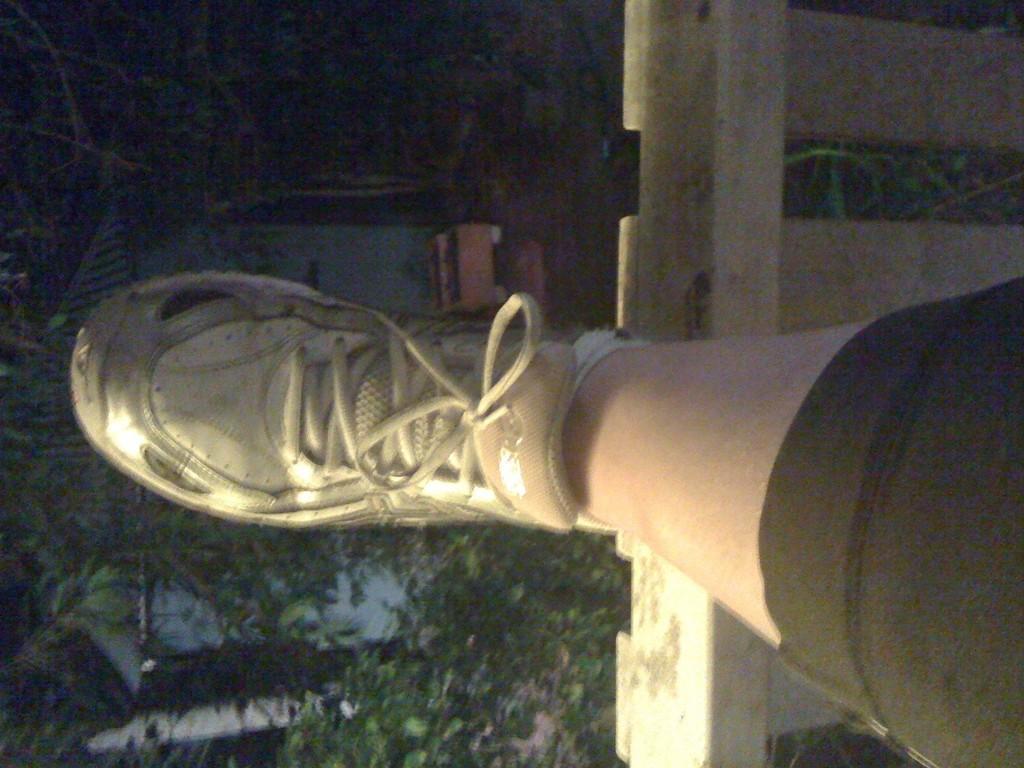In one or two sentences, can you explain what this image depicts? In this image I can see the person's leg with the shoe. To the left I can see the plants and there is a black background. 